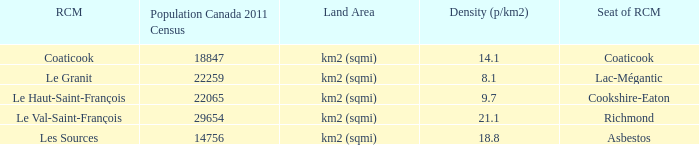What is the seat of the RCM in the county that has a density of 9.7? Cookshire-Eaton. 